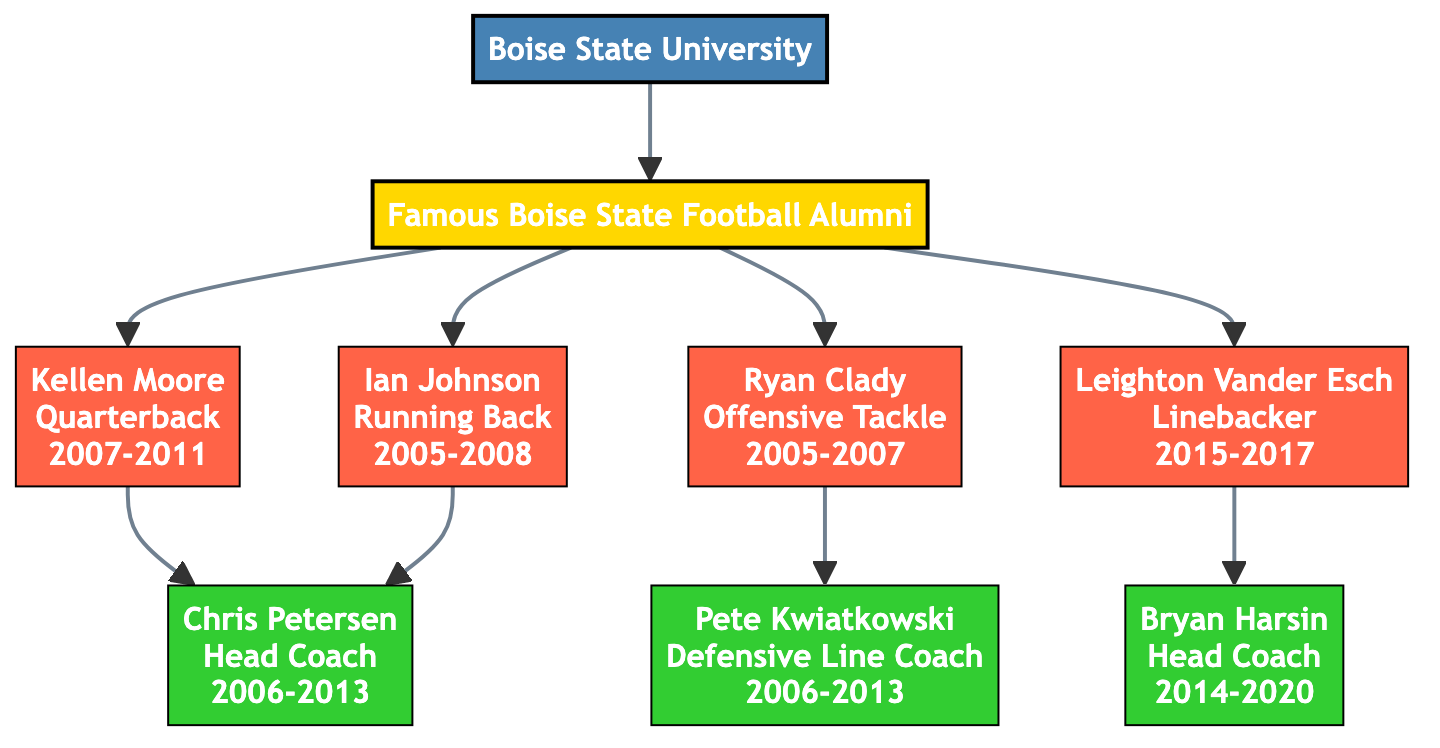What is the root of the family tree? The root of the family tree is "Boise State University," which connects to the famous alumni listed below.
Answer: Boise State University Who was the head coach during Kellen Moore's time? Kellen Moore is shown to be related to Chris Petersen, who was the head coach from 2006 to 2013 when Moore played.
Answer: Chris Petersen How many famous Boise State football alumni are depicted in the diagram? There are four notable alumni listed in the diagram: Kellen Moore, Ryan Clady, Ian Johnson, and Leighton Vander Esch.
Answer: 4 Which position did Ian Johnson play? The diagram indicates that Ian Johnson played the position of Running Back during his years at Boise State.
Answer: Running Back Who was the defensive line coach related to Ryan Clady? Ryan Clady is connected to Pete Kwiatkowski, who served as the Defensive Line Coach from 2006 to 2013.
Answer: Pete Kwiatkowski What years did Leighton Vander Esch play? The diagram specifies that Leighton Vander Esch played for Boise State from 2015 to 2017.
Answer: 2015-2017 Which two players are related to Chris Petersen? Both Kellen Moore and Ian Johnson are shown to have a connection to Chris Petersen, indicating they played during his tenure.
Answer: Kellen Moore, Ian Johnson Who coached Leighton Vander Esch? According to the diagram, Leighton Vander Esch was coached by Bryan Harsin from 2014 to 2020.
Answer: Bryan Harsin Which position is associated with Ryan Clady? The diagram indicates that Ryan Clady played the position of Offensive Tackle during his collegiate career.
Answer: Offensive Tackle 